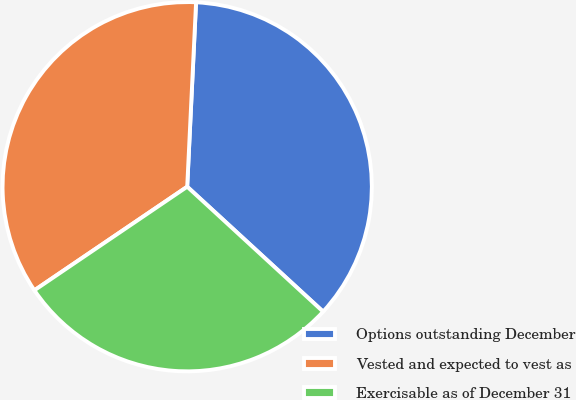Convert chart to OTSL. <chart><loc_0><loc_0><loc_500><loc_500><pie_chart><fcel>Options outstanding December<fcel>Vested and expected to vest as<fcel>Exercisable as of December 31<nl><fcel>36.07%<fcel>35.25%<fcel>28.69%<nl></chart> 